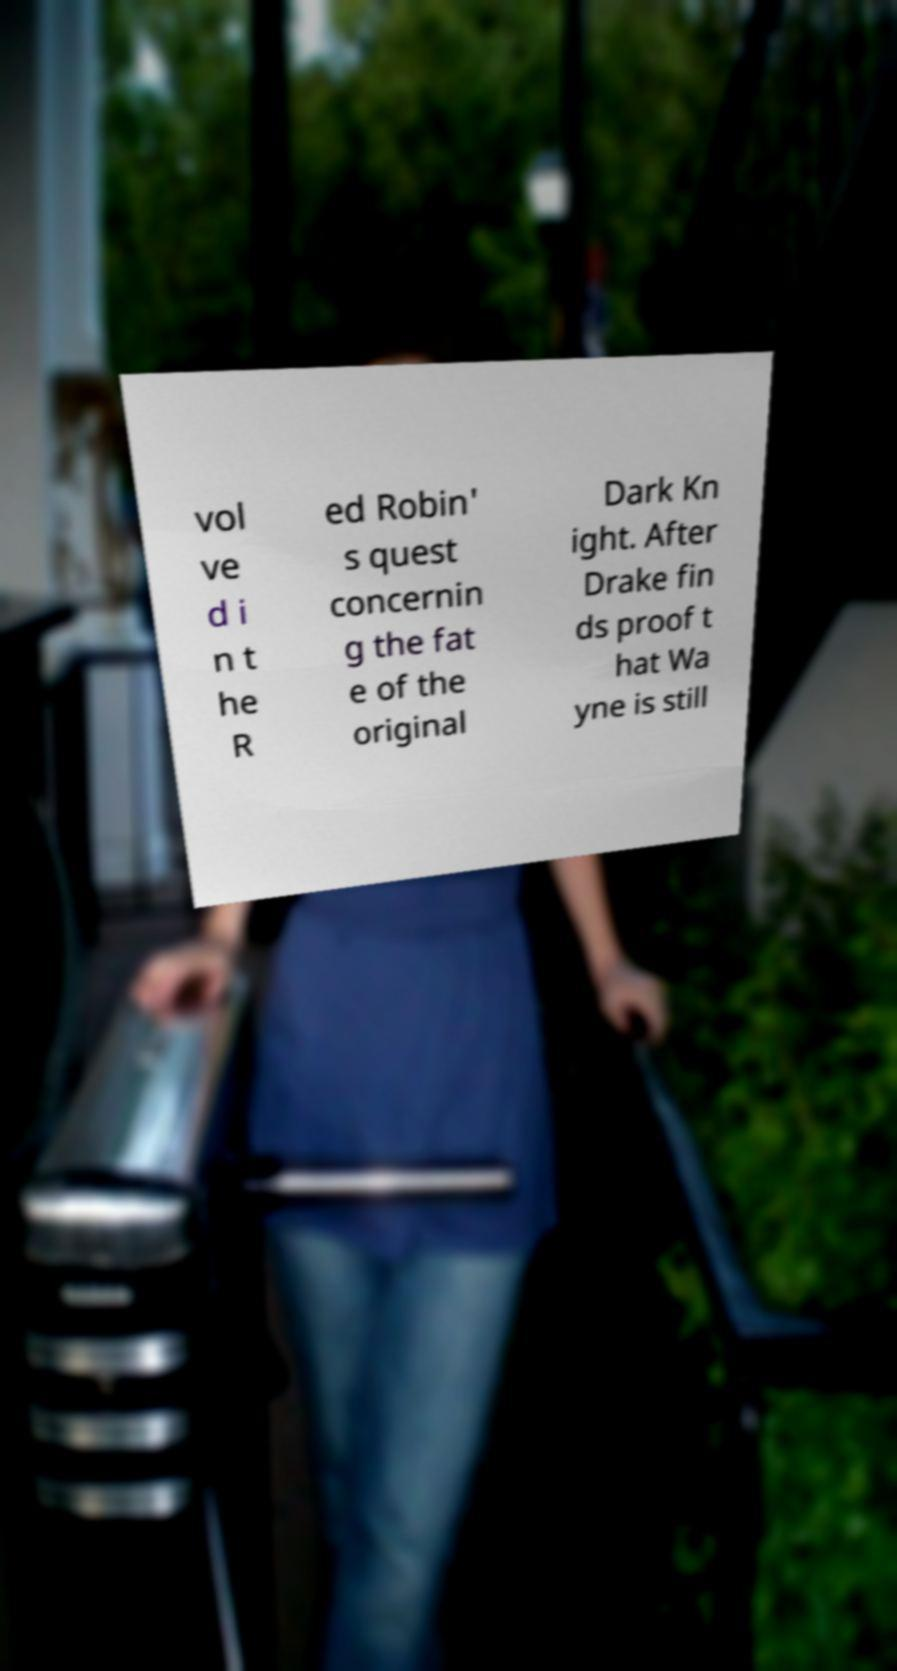Please identify and transcribe the text found in this image. vol ve d i n t he R ed Robin' s quest concernin g the fat e of the original Dark Kn ight. After Drake fin ds proof t hat Wa yne is still 